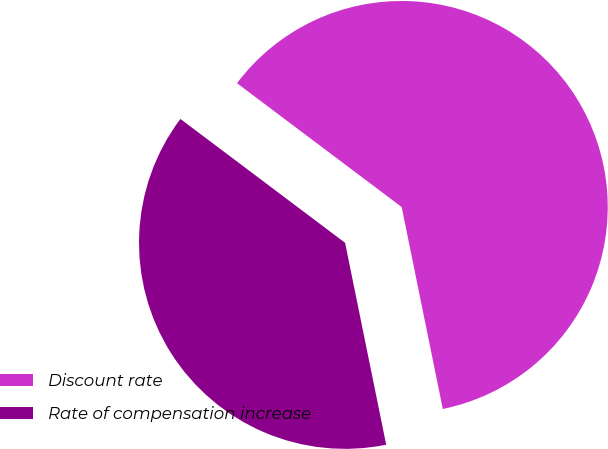Convert chart to OTSL. <chart><loc_0><loc_0><loc_500><loc_500><pie_chart><fcel>Discount rate<fcel>Rate of compensation increase<nl><fcel>61.54%<fcel>38.46%<nl></chart> 